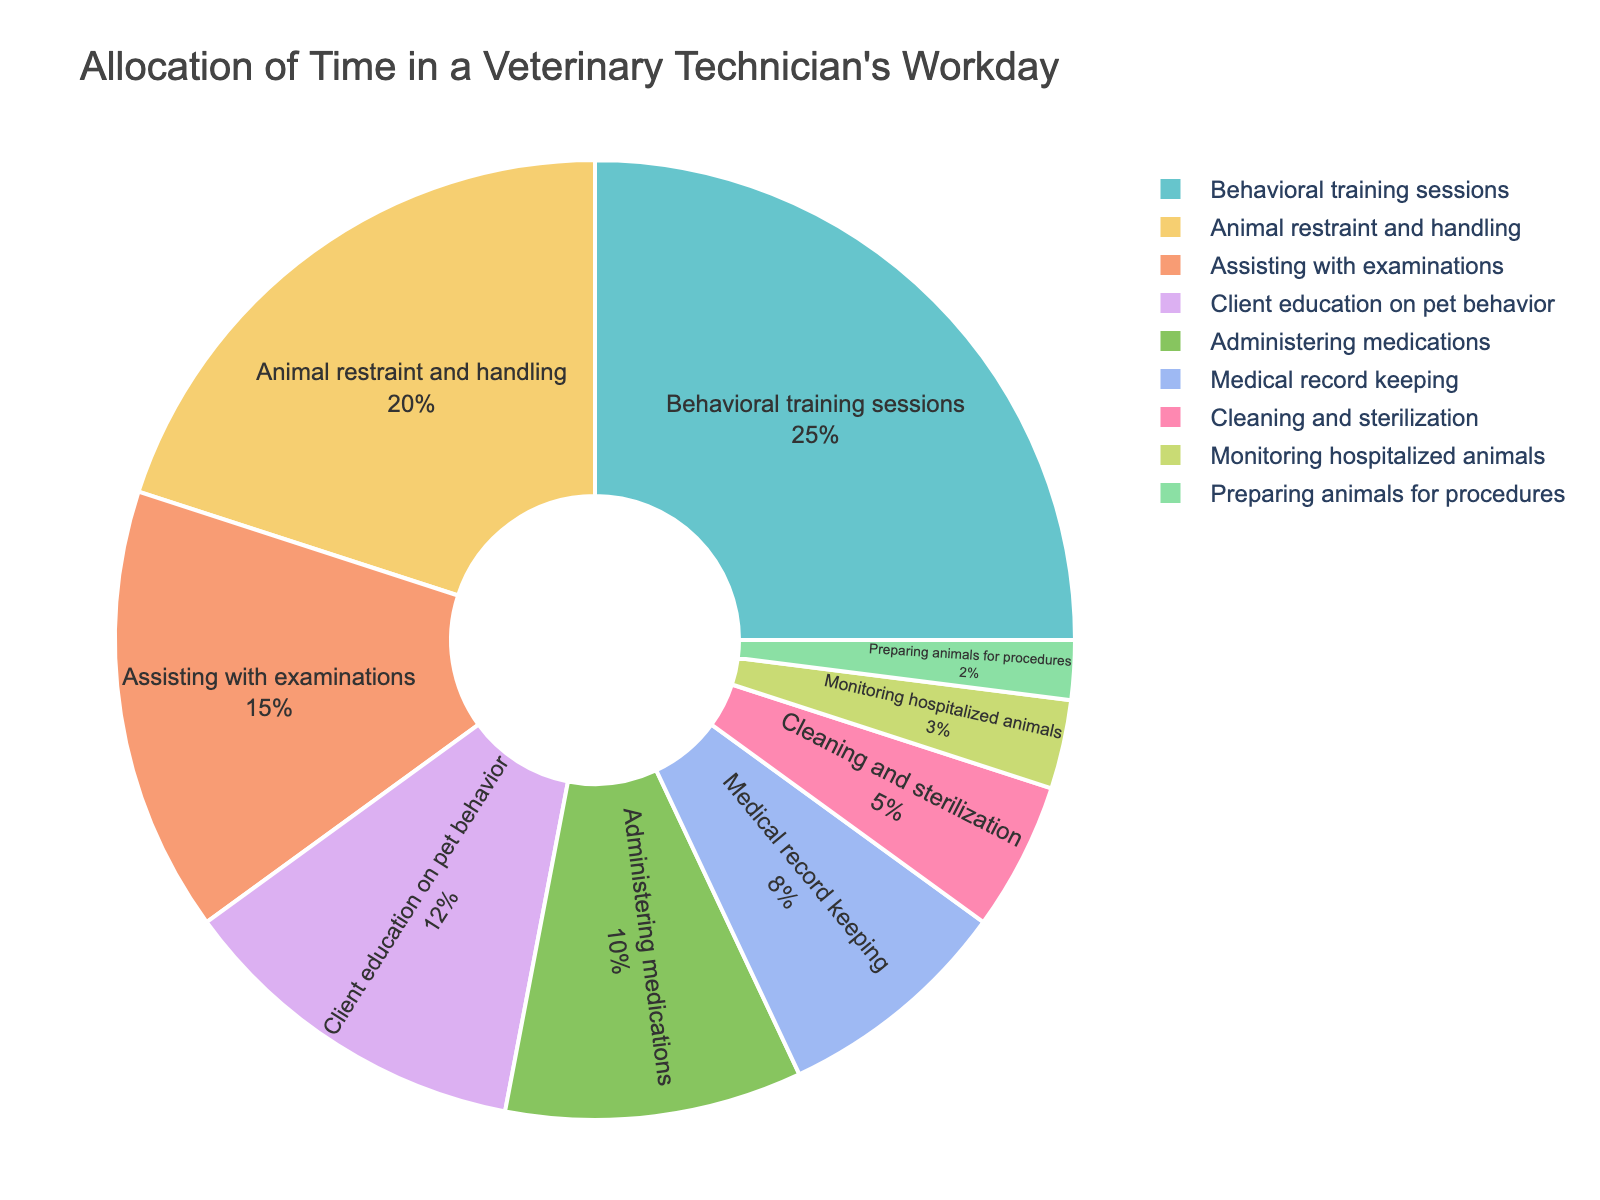Which task takes up the largest percentage of the workday? By looking at the pie chart, the largest section corresponds to the task with the highest percentage. "Behavioral training sessions" occupies the largest portion.
Answer: Behavioral training sessions How much more time is spent on behavioral training sessions than on administering medications? By referencing the percentages, time spent on behavioral training sessions is 25%, and on administering medications is 10%. The difference is calculated as 25% - 10%.
Answer: 15% What's the combined percentage of time spent on client education on pet behavior and monitoring hospitalized animals? Add the percentages for client education on pet behavior (12%) and monitoring hospitalized animals (3%). Sum them up to find the combined percentage.
Answer: 15% Which tasks have a percentage difference of 5% between them? Several tasks can be compared: animal restraint and handling (20%) and assisting with examinations (15%) have a 5% difference. Cleaning and sterilization (5%) and monitoring hospitalized animals (3%) also have this difference.
Answer: - Animal restraint and handling vs. Assisting with examinations
- Cleaning and sterilization vs. Monitoring hospitalized animals Which tasks take up less than 10% of the technician's workday? Tasks with percentages lower than 10% should be identified from the chart. These tasks are medical record keeping (8%), cleaning and sterilization (5%), monitoring hospitalized animals (3%), and preparing animals for procedures (2%).
Answer: Medical record keeping, Cleaning and sterilization, Monitoring hospitalized animals, Preparing animals for procedures How much more time is spent on behavioral training sessions compared to the total time spent on administering medications and preparing animals for procedures combined? Calculate the combined time for administering medications (10%) and preparing animals for procedures (2%) which is 12%. Then, subtract this from the time spent on behavioral training sessions (25%). The difference is 25% - 12%.
Answer: 13% If time spent on client education on pet behavior is increased by 3%, which task would had equal percentage with it? Increasing client education on pet behavior from 12% by 3% makes it 15%. Assisting with examinations is also 15%.
Answer: Assisting with examinations 